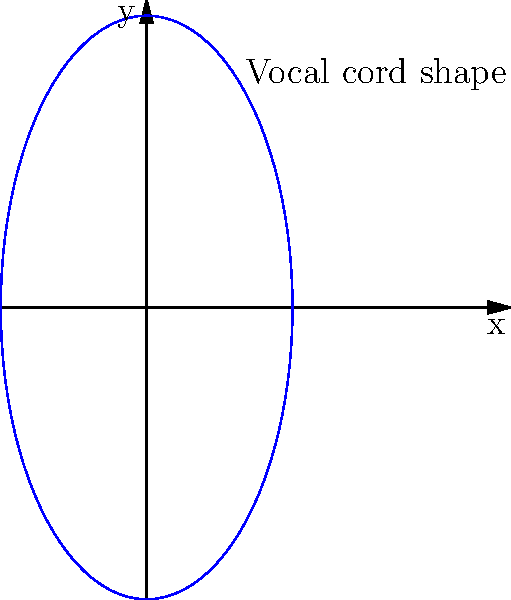The shape of a vocal cord during phonation can be modeled using the parametric equations:

$$ x(t) = 0.5\cos(t) $$
$$ y(t) = \sin(t) $$

where $t$ is the parameter ranging from 0 to $2\pi$. Calculate the curvature of the vocal cord at the point where $t = \frac{\pi}{2}$. To calculate the curvature, we'll use the formula for parametric curves:

$$ \kappa = \frac{|\dot{x}\ddot{y} - \dot{y}\ddot{x}|}{(\dot{x}^2 + \dot{y}^2)^{3/2}} $$

Step 1: Calculate the first and second derivatives of x(t) and y(t).
$\dot{x} = -0.5\sin(t)$
$\ddot{x} = -0.5\cos(t)$
$\dot{y} = \cos(t)$
$\ddot{y} = -\sin(t)$

Step 2: Evaluate the derivatives at $t = \frac{\pi}{2}$.
$\dot{x}(\frac{\pi}{2}) = -0.5$
$\ddot{x}(\frac{\pi}{2}) = 0$
$\dot{y}(\frac{\pi}{2}) = 0$
$\ddot{y}(\frac{\pi}{2}) = -1$

Step 3: Substitute these values into the curvature formula.
$$ \kappa = \frac{|(-0.5 \cdot -1) - (0 \cdot 0)|}{((-0.5)^2 + 0^2)^{3/2}} = \frac{0.5}{(0.25)^{3/2}} = \frac{0.5}{0.125} = 4 $$

Therefore, the curvature of the vocal cord at $t = \frac{\pi}{2}$ is 4.
Answer: 4 